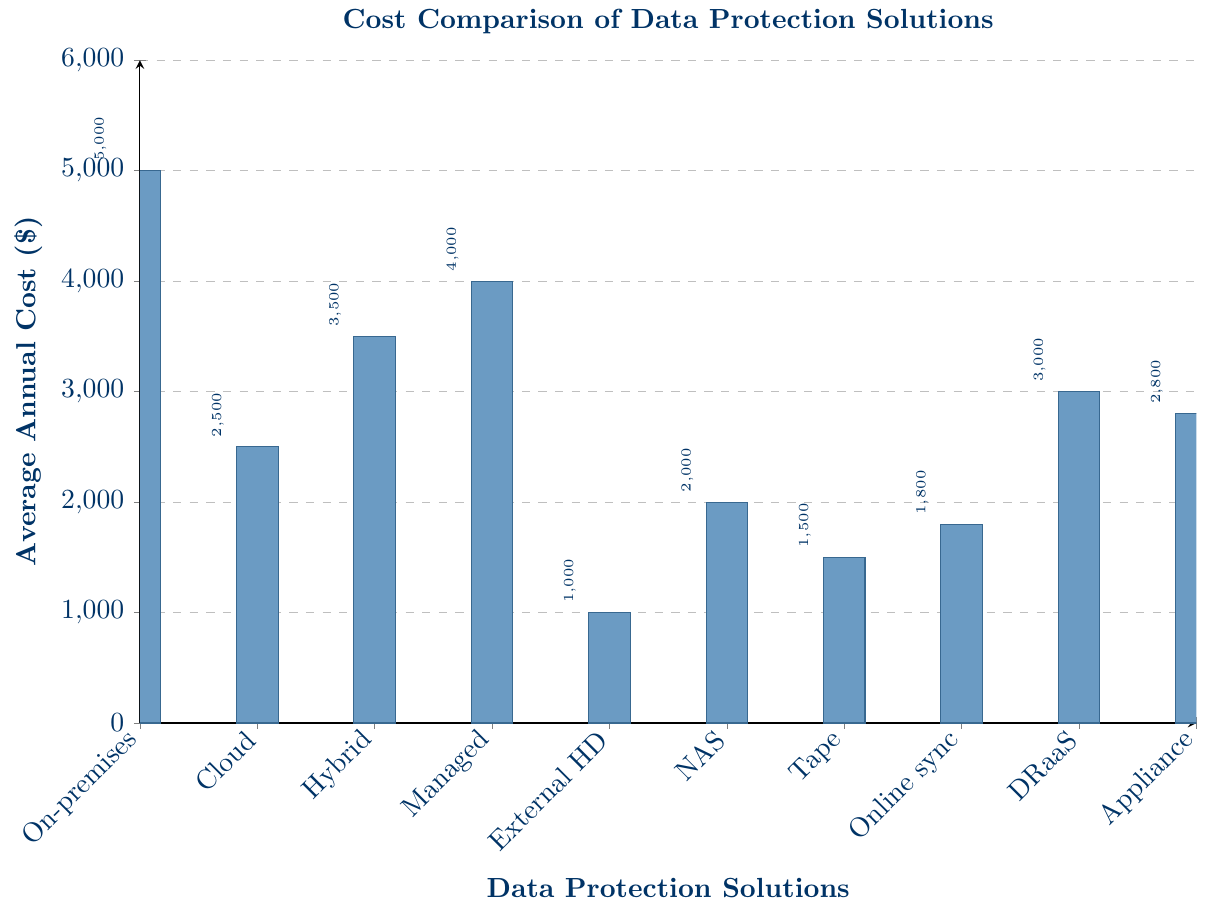What's the highest annual cost among all data protection solutions? The highest bar in the chart represents the maximum annual cost. The tallest bar corresponds to the "On-premises backup server" solution with an annual cost of $5,000.
Answer: $5,000 Which data protection solution has the lowest annual cost? The lowest bar in the chart represents the minimum annual cost. The shortest bar corresponds to the "External hard drive backup" solution with an annual cost of $1,000.
Answer: $1,000 By how much does the annual cost of the Hybrid backup solution exceed that of the NAS (Network Attached Storage) solution? Identify the heights of the bars for the Hybrid backup solution ($3,500) and NAS solution ($2,000). Calculate the difference: $3,500 - $2,000 = $1,500.
Answer: $1,500 What is the median cost of all the data protection solutions? List all costs in ascending order: $1,000, $1,500, $1,800, $2,000, $2,500, $2,800, $3,000, $3,500, $4,000, $5,000. The median is the average of the 5th and 6th elements: ($2,500 + $2,800) / 2 = $2,650.
Answer: $2,650 Which solution costs more: Managed backup service or Disaster recovery as a service (DRaaS)? Compare the heights of the bars for "Managed backup service" ($4,000) and "DRaaS" ($3,000). The Managed backup service is higher.
Answer: Managed backup service How many solutions have an annual cost less than $3,000? Identify bars with heights less than $3,000. These are: External hard drive backup ($1,000), Tape backup ($1,500), Online file sync and share ($1,800), NAS ($2,000), Cloud backup service ($2,500), and Backup appliance ($2,800) – a total of 6 solutions.
Answer: 6 What is the total annual cost if a business uses both the Cloud backup service and the Tape backup? Find the heights of the bars for "Cloud backup service" ($2,500) and "Tape backup" ($1,500). Sum them: $2,500 + $1,500 = $4,000.
Answer: $4,000 Which type of solutions are generally more economical: physical (e.g., External hard drive, NAS) or service-based (e.g., Cloud, DRaaS)? Compare the cost ranges of bars related to physical solutions: External hard drive ($1,000), NAS ($2,000), Tape backup ($1,500) with service-based solutions: Cloud ($2,500), DRaaS ($3,000). Physical solutions generally have bars in the lower end.
Answer: Physical solutions 